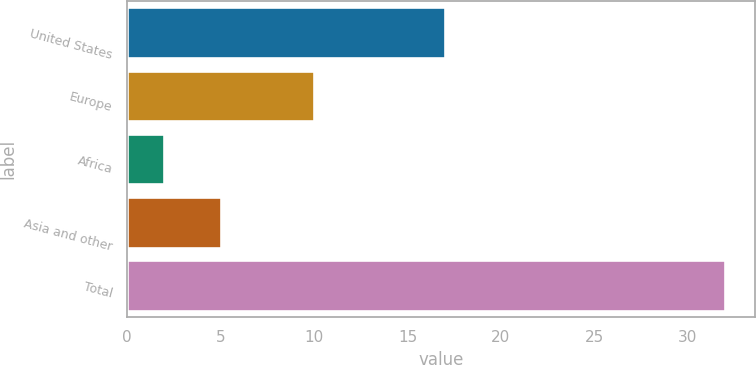Convert chart. <chart><loc_0><loc_0><loc_500><loc_500><bar_chart><fcel>United States<fcel>Europe<fcel>Africa<fcel>Asia and other<fcel>Total<nl><fcel>17<fcel>10<fcel>2<fcel>5<fcel>32<nl></chart> 